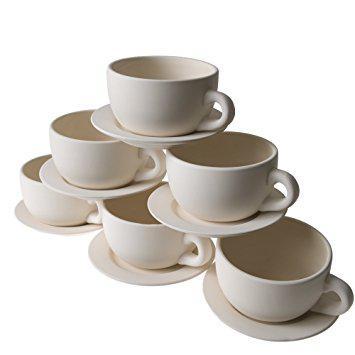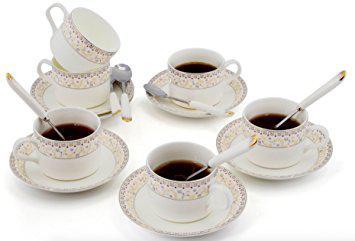The first image is the image on the left, the second image is the image on the right. Evaluate the accuracy of this statement regarding the images: "There is a teapot in one of the images.". Is it true? Answer yes or no. No. 